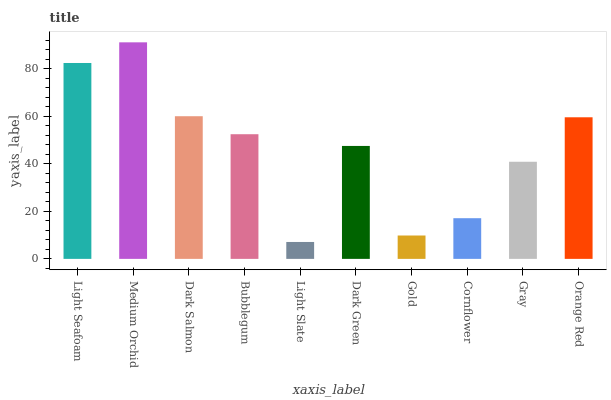Is Dark Salmon the minimum?
Answer yes or no. No. Is Dark Salmon the maximum?
Answer yes or no. No. Is Medium Orchid greater than Dark Salmon?
Answer yes or no. Yes. Is Dark Salmon less than Medium Orchid?
Answer yes or no. Yes. Is Dark Salmon greater than Medium Orchid?
Answer yes or no. No. Is Medium Orchid less than Dark Salmon?
Answer yes or no. No. Is Bubblegum the high median?
Answer yes or no. Yes. Is Dark Green the low median?
Answer yes or no. Yes. Is Orange Red the high median?
Answer yes or no. No. Is Dark Salmon the low median?
Answer yes or no. No. 